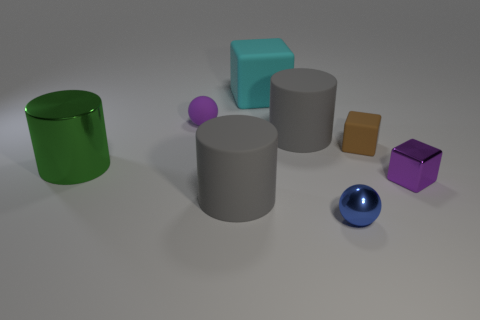Add 1 tiny green balls. How many objects exist? 9 Subtract all cylinders. How many objects are left? 5 Add 4 blue metallic objects. How many blue metallic objects exist? 5 Subtract 1 gray cylinders. How many objects are left? 7 Subtract all large yellow objects. Subtract all rubber cylinders. How many objects are left? 6 Add 2 gray cylinders. How many gray cylinders are left? 4 